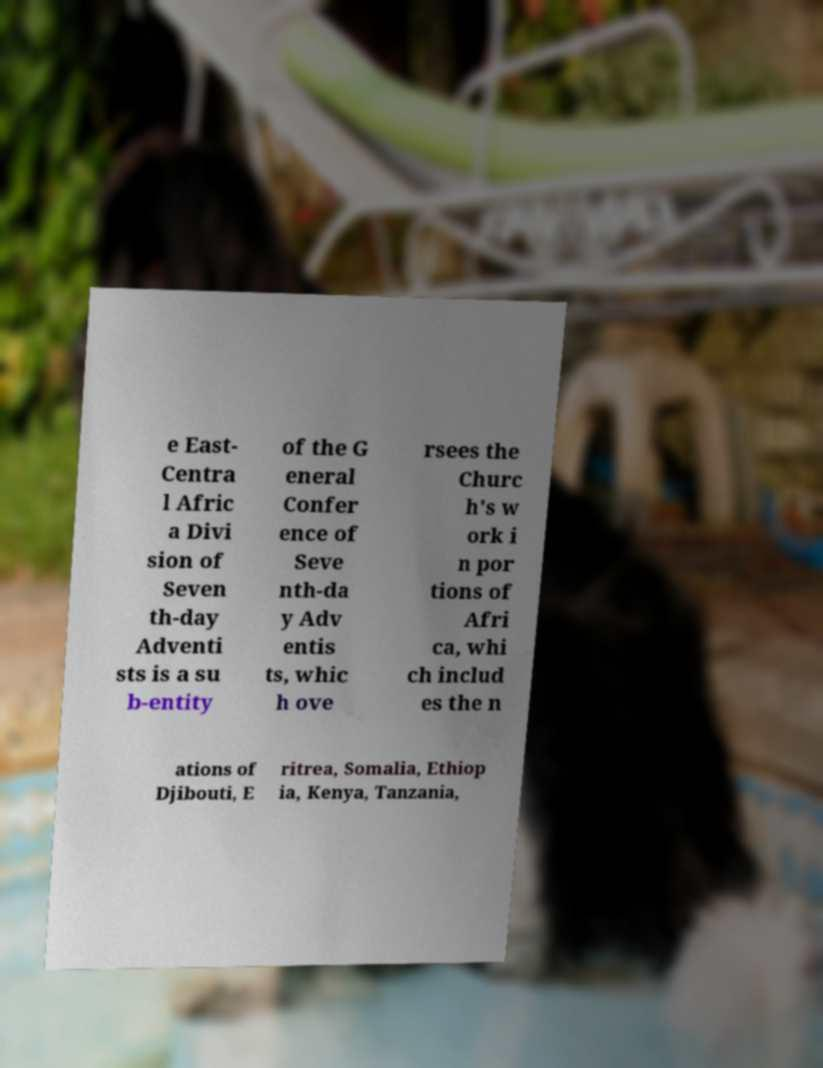What messages or text are displayed in this image? I need them in a readable, typed format. e East- Centra l Afric a Divi sion of Seven th-day Adventi sts is a su b-entity of the G eneral Confer ence of Seve nth-da y Adv entis ts, whic h ove rsees the Churc h's w ork i n por tions of Afri ca, whi ch includ es the n ations of Djibouti, E ritrea, Somalia, Ethiop ia, Kenya, Tanzania, 